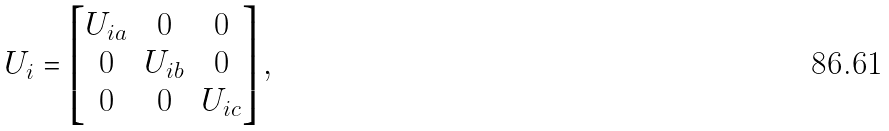Convert formula to latex. <formula><loc_0><loc_0><loc_500><loc_500>U _ { i } = \begin{bmatrix} U _ { i a } & 0 & 0 \\ 0 & U _ { i b } & 0 \\ 0 & 0 & U _ { i c } \end{bmatrix} ,</formula> 